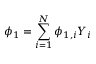Convert formula to latex. <formula><loc_0><loc_0><loc_500><loc_500>\phi _ { 1 } = \sum _ { i = 1 } ^ { N } \phi _ { 1 , i } Y _ { i }</formula> 